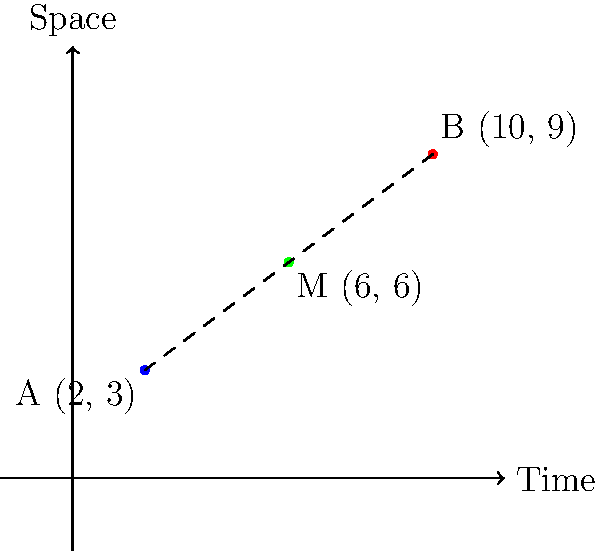In a thrilling episode of "The Twilight Zone," Rod Serling introduces a time-travel adventure where two explorers visit different points in space-time. Explorer A lands at coordinates (2, 3), while Explorer B arrives at (10, 9). To ensure they can meet halfway through their journey, they need to calculate the midpoint of their time-travel path. What are the coordinates of this midpoint M? To find the midpoint of a line segment connecting two points, we can use the midpoint formula:

$$ M_x = \frac{x_1 + x_2}{2}, \quad M_y = \frac{y_1 + y_2}{2} $$

Where $(x_1, y_1)$ are the coordinates of point A, and $(x_2, y_2)$ are the coordinates of point B.

Step 1: Identify the coordinates
Point A: $(x_1, y_1) = (2, 3)$
Point B: $(x_2, y_2) = (10, 9)$

Step 2: Calculate the x-coordinate of the midpoint
$$ M_x = \frac{x_1 + x_2}{2} = \frac{2 + 10}{2} = \frac{12}{2} = 6 $$

Step 3: Calculate the y-coordinate of the midpoint
$$ M_y = \frac{y_1 + y_2}{2} = \frac{3 + 9}{2} = \frac{12}{2} = 6 $$

Step 4: Combine the results
The midpoint M has coordinates $(M_x, M_y) = (6, 6)$

This point represents the location in space-time where the two explorers can meet halfway through their journey, reminiscent of the mind-bending plots often found in classic sci-fi shows.
Answer: (6, 6) 